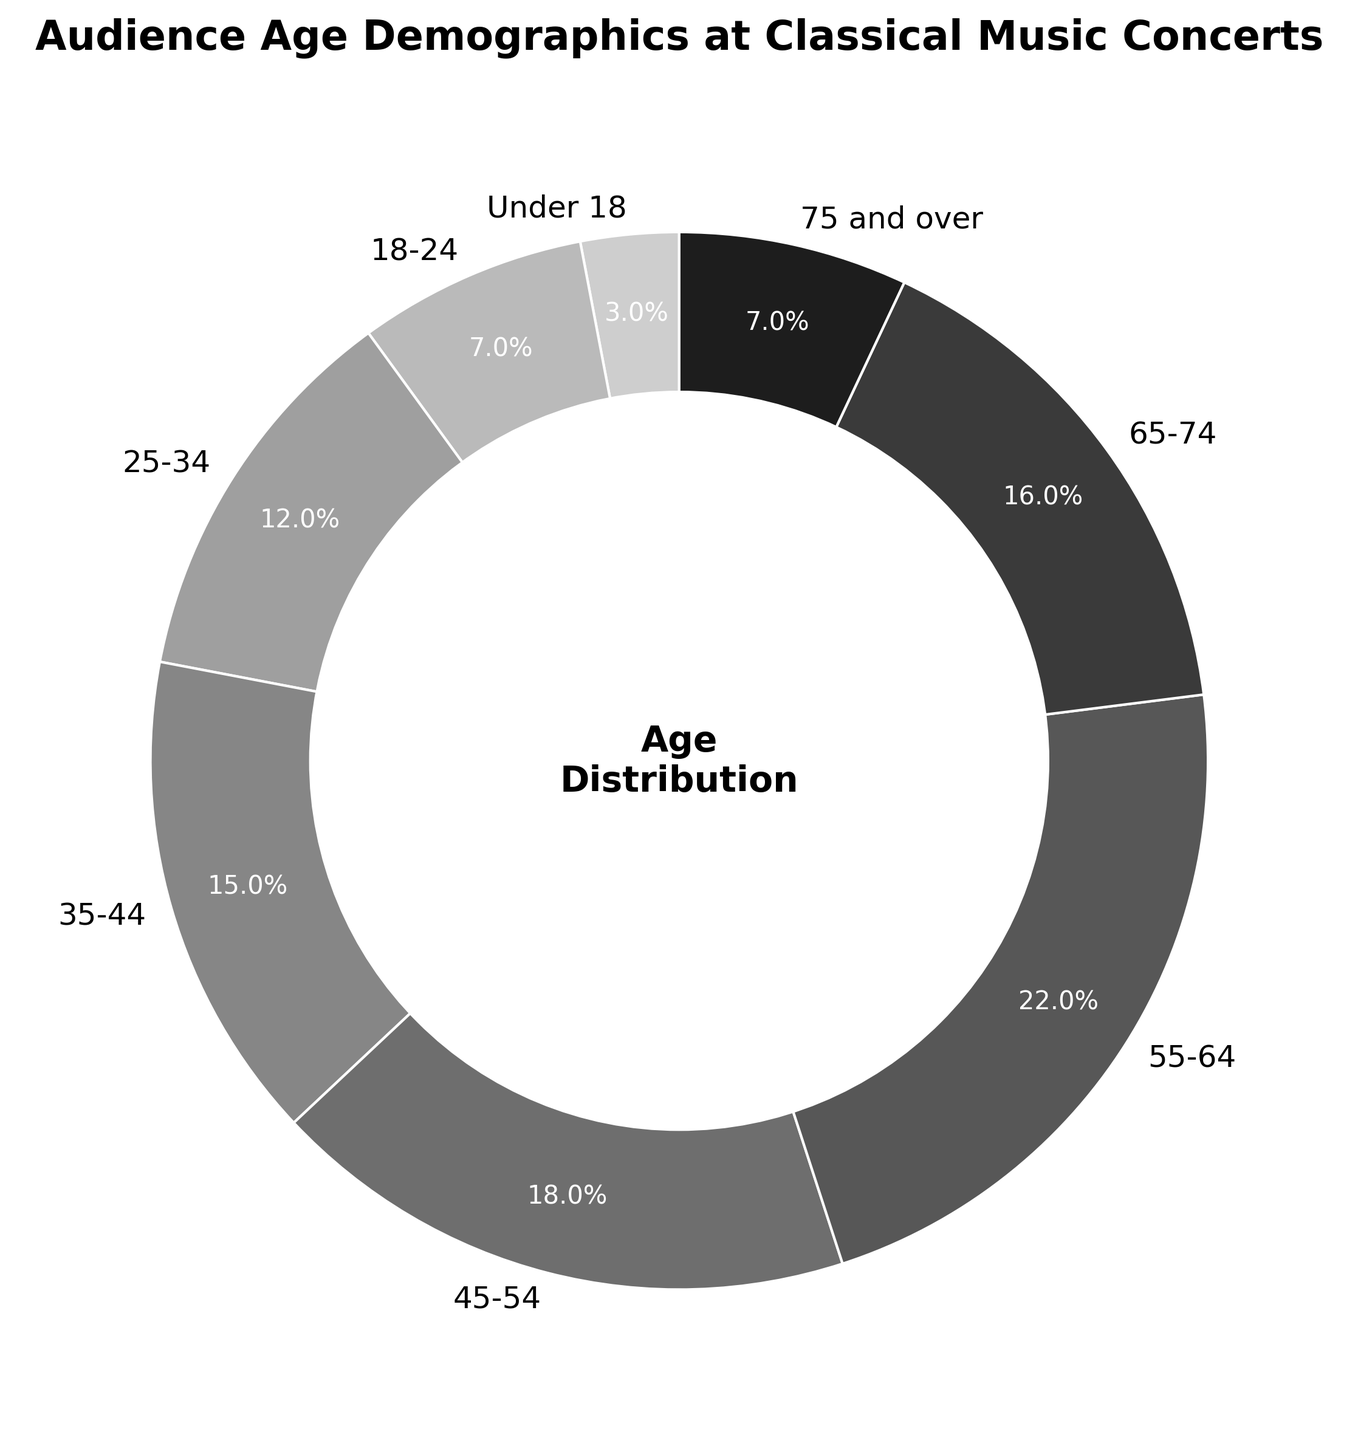What age group has the highest percentage of attendance at classical music concerts? By looking at the pie chart, we see that the 55-64 age group has the largest segment.
Answer: 55-64 What is the combined percentage of attendees who are 65 and older? Add the percentages of the 65-74 and 75 and over groups: 16% + 7% = 23%.
Answer: 23% Which age group has a higher attendance percentage, the 35-44 or 45-54 group? Compare the two segments on the chart: 35-44 is 15%, and 45-54 is 18%.
Answer: 45-54 What is the total percentage of concertgoers who are between 18 and 24 and under 18? Add the percentages for under 18 and 18-24: 3% + 7% = 10%.
Answer: 10% Is the percentage of the 25-34 age group greater or less than the percentage of the 65-74 age group? Compare the two segments on the chart: 25-34 is 12% and 65-74 is 16%.
Answer: Less How many age groups have a percentage greater than 15%? Identify age groups with more than 15%: 35-44 (15%), 45-54 (18%), 55-64 (22%), 65-74 (16%). This sums up to 3 groups.
Answer: 3 What age group has the same percentage of attendance as the 18-24 group? The percentage for the 18-24 age group is 7%, and another group with the same percentage is 75 and over.
Answer: 75 and over How much greater is the attendance percentage for the 55-64 age group compared to the 25-34 age group? Subtract the percentage of 25-34 from 55-64: 22% - 12% = 10%.
Answer: 10% What is the average percentage of attendance for the age groups 18-24, 25-34, and 35-44? Calculate the average: (7% + 12% + 15%) / 3 = 11.33%.
Answer: 11.33% 